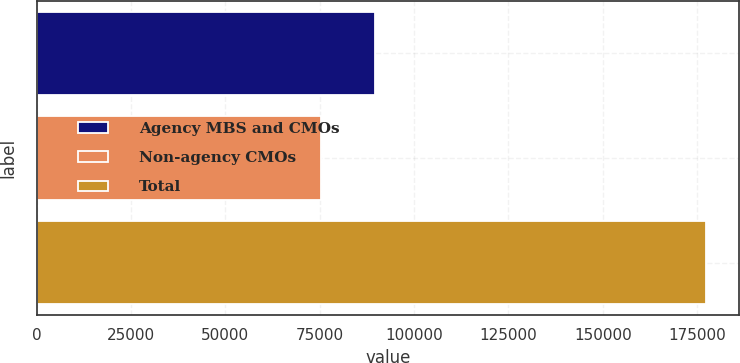Convert chart to OTSL. <chart><loc_0><loc_0><loc_500><loc_500><bar_chart><fcel>Agency MBS and CMOs<fcel>Non-agency CMOs<fcel>Total<nl><fcel>89750<fcel>75476<fcel>177298<nl></chart> 